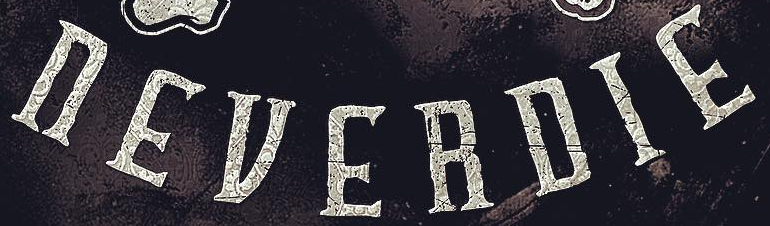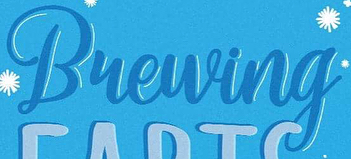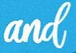Identify the words shown in these images in order, separated by a semicolon. nEVERDIE; Bueuing; and 